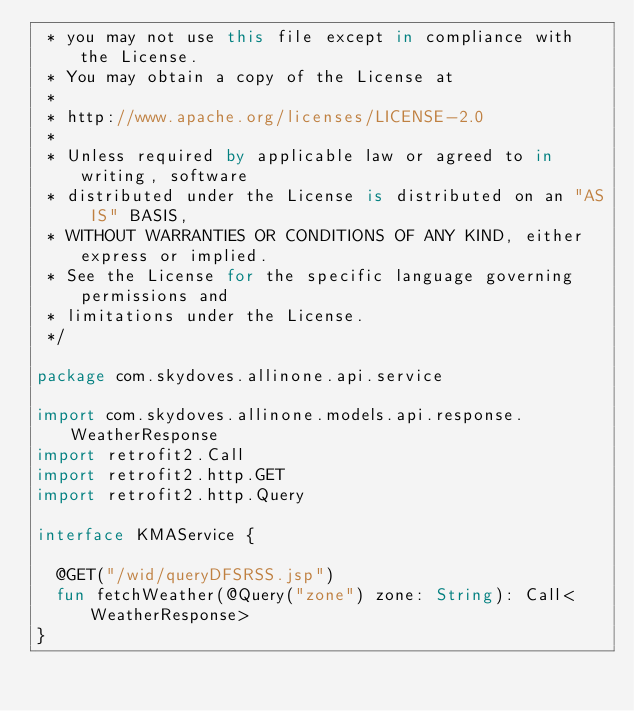<code> <loc_0><loc_0><loc_500><loc_500><_Kotlin_> * you may not use this file except in compliance with the License.
 * You may obtain a copy of the License at
 *
 * http://www.apache.org/licenses/LICENSE-2.0
 *
 * Unless required by applicable law or agreed to in writing, software
 * distributed under the License is distributed on an "AS IS" BASIS,
 * WITHOUT WARRANTIES OR CONDITIONS OF ANY KIND, either express or implied.
 * See the License for the specific language governing permissions and
 * limitations under the License.
 */

package com.skydoves.allinone.api.service

import com.skydoves.allinone.models.api.response.WeatherResponse
import retrofit2.Call
import retrofit2.http.GET
import retrofit2.http.Query

interface KMAService {

  @GET("/wid/queryDFSRSS.jsp")
  fun fetchWeather(@Query("zone") zone: String): Call<WeatherResponse>
}
</code> 